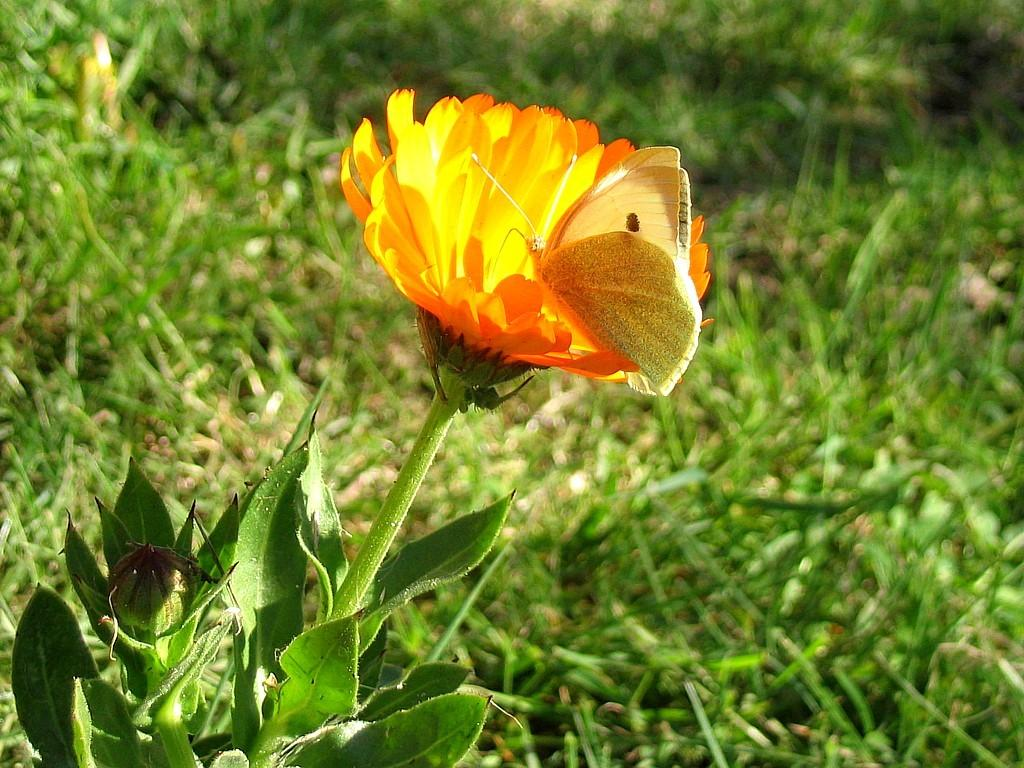What is the main subject of the image? There is a butterfly on a flower in the image. Can you describe the flower in the image? There is a flower bud in the image. What other plant parts can be seen in the image? Leaves and stems are visible in the image. How would you describe the background of the image? The background has a blurred view. What type of vegetation is present in the image? Grass is present in the image. What type of wrench is being used by the ghost in the image? There is no ghost or wrench present in the image; it features a butterfly on a flower with other plant elements. 